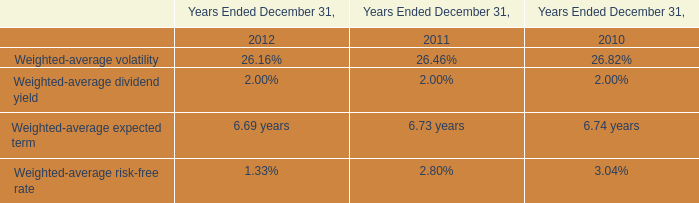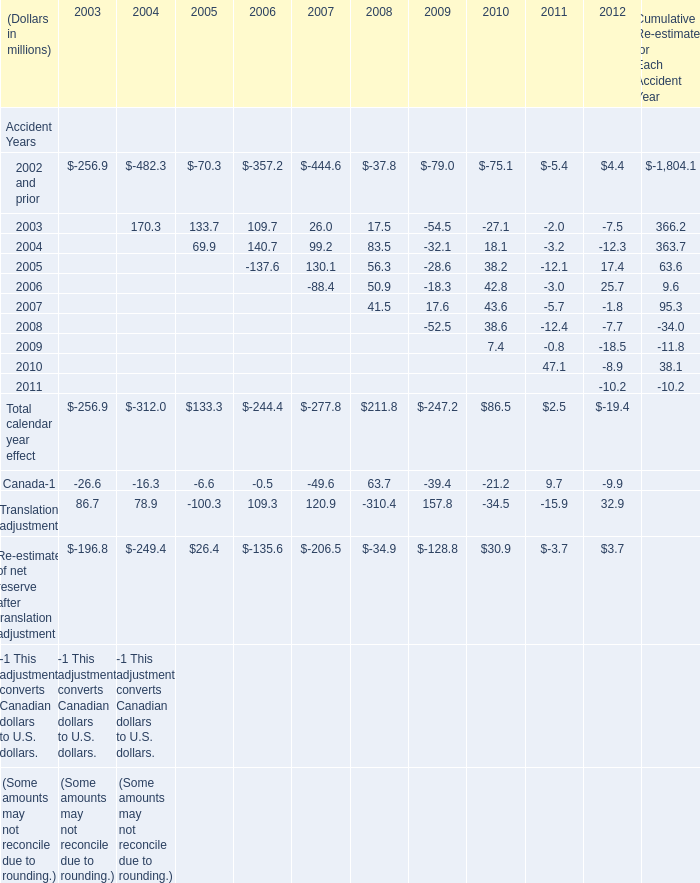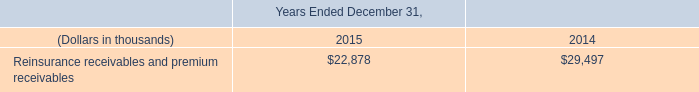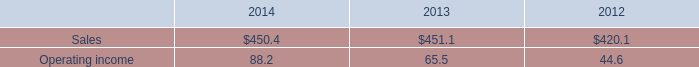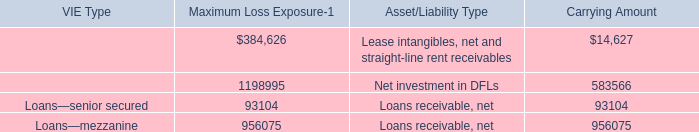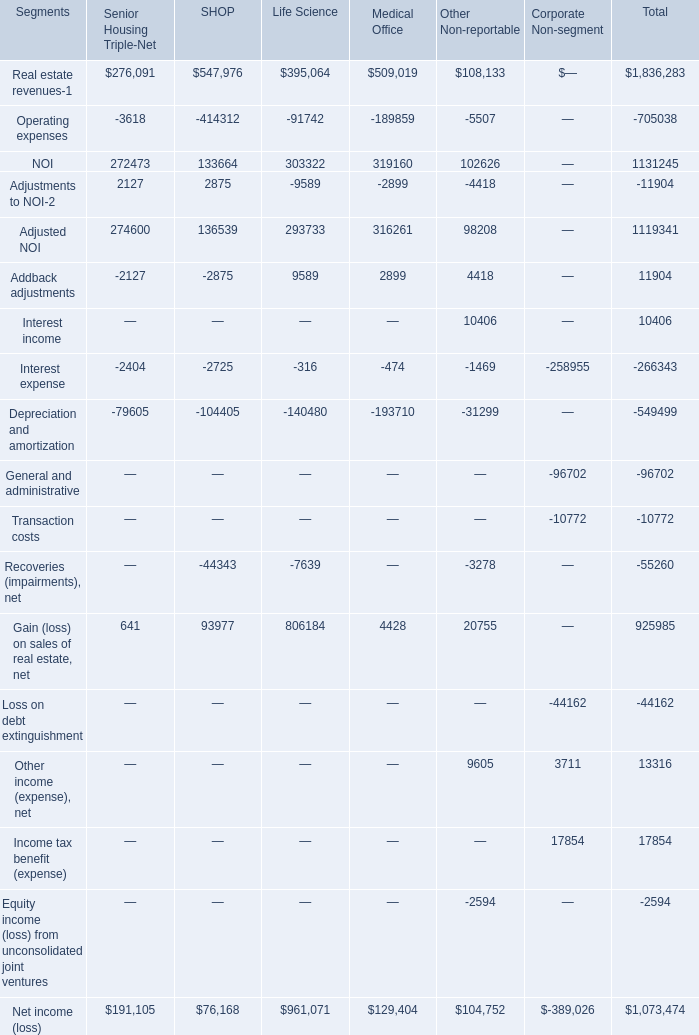What is the average amount of VIE tenants—DFLs of Carrying Amount, and Operating expenses of SHOP ? 
Computations: ((583566.0 + 414312.0) / 2)
Answer: 498939.0. 